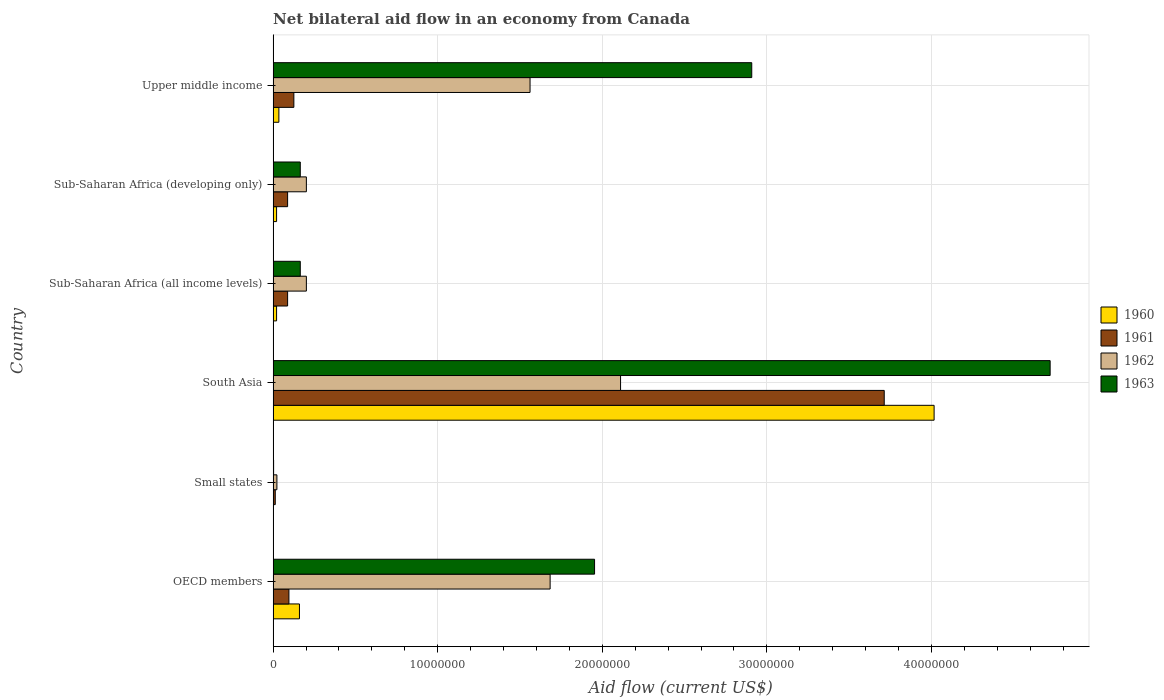How many groups of bars are there?
Your answer should be compact. 6. Are the number of bars on each tick of the Y-axis equal?
Keep it short and to the point. Yes. What is the label of the 6th group of bars from the top?
Ensure brevity in your answer.  OECD members. What is the net bilateral aid flow in 1963 in Sub-Saharan Africa (all income levels)?
Your answer should be compact. 1.65e+06. Across all countries, what is the maximum net bilateral aid flow in 1960?
Your response must be concise. 4.02e+07. In which country was the net bilateral aid flow in 1960 maximum?
Offer a very short reply. South Asia. In which country was the net bilateral aid flow in 1963 minimum?
Your answer should be compact. Small states. What is the total net bilateral aid flow in 1961 in the graph?
Your response must be concise. 4.12e+07. What is the difference between the net bilateral aid flow in 1961 in South Asia and that in Sub-Saharan Africa (all income levels)?
Your answer should be very brief. 3.62e+07. What is the difference between the net bilateral aid flow in 1963 in South Asia and the net bilateral aid flow in 1960 in Small states?
Keep it short and to the point. 4.72e+07. What is the average net bilateral aid flow in 1961 per country?
Ensure brevity in your answer.  6.87e+06. What is the difference between the net bilateral aid flow in 1963 and net bilateral aid flow in 1961 in OECD members?
Your answer should be very brief. 1.86e+07. In how many countries, is the net bilateral aid flow in 1960 greater than 28000000 US$?
Offer a very short reply. 1. What is the ratio of the net bilateral aid flow in 1961 in Small states to that in Sub-Saharan Africa (developing only)?
Your answer should be compact. 0.15. Is the net bilateral aid flow in 1962 in Sub-Saharan Africa (developing only) less than that in Upper middle income?
Offer a very short reply. Yes. Is the difference between the net bilateral aid flow in 1963 in Small states and Sub-Saharan Africa (developing only) greater than the difference between the net bilateral aid flow in 1961 in Small states and Sub-Saharan Africa (developing only)?
Offer a very short reply. No. What is the difference between the highest and the second highest net bilateral aid flow in 1961?
Offer a very short reply. 3.59e+07. What is the difference between the highest and the lowest net bilateral aid flow in 1961?
Make the answer very short. 3.70e+07. Is the sum of the net bilateral aid flow in 1960 in Small states and Upper middle income greater than the maximum net bilateral aid flow in 1963 across all countries?
Offer a terse response. No. How many countries are there in the graph?
Your answer should be compact. 6. What is the difference between two consecutive major ticks on the X-axis?
Keep it short and to the point. 1.00e+07. Are the values on the major ticks of X-axis written in scientific E-notation?
Offer a terse response. No. Does the graph contain any zero values?
Your answer should be very brief. No. Does the graph contain grids?
Provide a succinct answer. Yes. How many legend labels are there?
Your answer should be compact. 4. What is the title of the graph?
Provide a succinct answer. Net bilateral aid flow in an economy from Canada. What is the label or title of the X-axis?
Give a very brief answer. Aid flow (current US$). What is the label or title of the Y-axis?
Your answer should be very brief. Country. What is the Aid flow (current US$) of 1960 in OECD members?
Provide a short and direct response. 1.60e+06. What is the Aid flow (current US$) in 1961 in OECD members?
Your response must be concise. 9.60e+05. What is the Aid flow (current US$) in 1962 in OECD members?
Give a very brief answer. 1.68e+07. What is the Aid flow (current US$) of 1963 in OECD members?
Ensure brevity in your answer.  1.95e+07. What is the Aid flow (current US$) of 1960 in Small states?
Your answer should be very brief. 2.00e+04. What is the Aid flow (current US$) in 1962 in Small states?
Provide a short and direct response. 2.30e+05. What is the Aid flow (current US$) of 1960 in South Asia?
Offer a terse response. 4.02e+07. What is the Aid flow (current US$) of 1961 in South Asia?
Make the answer very short. 3.71e+07. What is the Aid flow (current US$) in 1962 in South Asia?
Offer a very short reply. 2.11e+07. What is the Aid flow (current US$) in 1963 in South Asia?
Offer a terse response. 4.72e+07. What is the Aid flow (current US$) of 1960 in Sub-Saharan Africa (all income levels)?
Keep it short and to the point. 2.10e+05. What is the Aid flow (current US$) in 1961 in Sub-Saharan Africa (all income levels)?
Ensure brevity in your answer.  8.80e+05. What is the Aid flow (current US$) in 1962 in Sub-Saharan Africa (all income levels)?
Offer a very short reply. 2.02e+06. What is the Aid flow (current US$) in 1963 in Sub-Saharan Africa (all income levels)?
Offer a terse response. 1.65e+06. What is the Aid flow (current US$) in 1961 in Sub-Saharan Africa (developing only)?
Give a very brief answer. 8.80e+05. What is the Aid flow (current US$) of 1962 in Sub-Saharan Africa (developing only)?
Provide a succinct answer. 2.02e+06. What is the Aid flow (current US$) of 1963 in Sub-Saharan Africa (developing only)?
Provide a short and direct response. 1.65e+06. What is the Aid flow (current US$) in 1960 in Upper middle income?
Give a very brief answer. 3.50e+05. What is the Aid flow (current US$) of 1961 in Upper middle income?
Offer a very short reply. 1.26e+06. What is the Aid flow (current US$) of 1962 in Upper middle income?
Your response must be concise. 1.56e+07. What is the Aid flow (current US$) in 1963 in Upper middle income?
Your answer should be compact. 2.91e+07. Across all countries, what is the maximum Aid flow (current US$) of 1960?
Give a very brief answer. 4.02e+07. Across all countries, what is the maximum Aid flow (current US$) of 1961?
Your answer should be very brief. 3.71e+07. Across all countries, what is the maximum Aid flow (current US$) in 1962?
Keep it short and to the point. 2.11e+07. Across all countries, what is the maximum Aid flow (current US$) of 1963?
Your answer should be compact. 4.72e+07. What is the total Aid flow (current US$) in 1960 in the graph?
Your answer should be compact. 4.26e+07. What is the total Aid flow (current US$) in 1961 in the graph?
Ensure brevity in your answer.  4.12e+07. What is the total Aid flow (current US$) in 1962 in the graph?
Provide a succinct answer. 5.78e+07. What is the total Aid flow (current US$) in 1963 in the graph?
Give a very brief answer. 9.92e+07. What is the difference between the Aid flow (current US$) in 1960 in OECD members and that in Small states?
Give a very brief answer. 1.58e+06. What is the difference between the Aid flow (current US$) of 1961 in OECD members and that in Small states?
Ensure brevity in your answer.  8.30e+05. What is the difference between the Aid flow (current US$) of 1962 in OECD members and that in Small states?
Provide a short and direct response. 1.66e+07. What is the difference between the Aid flow (current US$) of 1963 in OECD members and that in Small states?
Your answer should be very brief. 1.95e+07. What is the difference between the Aid flow (current US$) of 1960 in OECD members and that in South Asia?
Ensure brevity in your answer.  -3.86e+07. What is the difference between the Aid flow (current US$) in 1961 in OECD members and that in South Asia?
Provide a short and direct response. -3.62e+07. What is the difference between the Aid flow (current US$) in 1962 in OECD members and that in South Asia?
Offer a terse response. -4.28e+06. What is the difference between the Aid flow (current US$) of 1963 in OECD members and that in South Asia?
Offer a very short reply. -2.77e+07. What is the difference between the Aid flow (current US$) of 1960 in OECD members and that in Sub-Saharan Africa (all income levels)?
Offer a very short reply. 1.39e+06. What is the difference between the Aid flow (current US$) of 1962 in OECD members and that in Sub-Saharan Africa (all income levels)?
Your answer should be very brief. 1.48e+07. What is the difference between the Aid flow (current US$) of 1963 in OECD members and that in Sub-Saharan Africa (all income levels)?
Keep it short and to the point. 1.79e+07. What is the difference between the Aid flow (current US$) of 1960 in OECD members and that in Sub-Saharan Africa (developing only)?
Keep it short and to the point. 1.39e+06. What is the difference between the Aid flow (current US$) of 1961 in OECD members and that in Sub-Saharan Africa (developing only)?
Give a very brief answer. 8.00e+04. What is the difference between the Aid flow (current US$) of 1962 in OECD members and that in Sub-Saharan Africa (developing only)?
Offer a very short reply. 1.48e+07. What is the difference between the Aid flow (current US$) in 1963 in OECD members and that in Sub-Saharan Africa (developing only)?
Give a very brief answer. 1.79e+07. What is the difference between the Aid flow (current US$) of 1960 in OECD members and that in Upper middle income?
Your response must be concise. 1.25e+06. What is the difference between the Aid flow (current US$) in 1961 in OECD members and that in Upper middle income?
Offer a very short reply. -3.00e+05. What is the difference between the Aid flow (current US$) of 1962 in OECD members and that in Upper middle income?
Ensure brevity in your answer.  1.22e+06. What is the difference between the Aid flow (current US$) in 1963 in OECD members and that in Upper middle income?
Your answer should be compact. -9.55e+06. What is the difference between the Aid flow (current US$) of 1960 in Small states and that in South Asia?
Ensure brevity in your answer.  -4.01e+07. What is the difference between the Aid flow (current US$) of 1961 in Small states and that in South Asia?
Ensure brevity in your answer.  -3.70e+07. What is the difference between the Aid flow (current US$) in 1962 in Small states and that in South Asia?
Offer a very short reply. -2.09e+07. What is the difference between the Aid flow (current US$) of 1963 in Small states and that in South Asia?
Ensure brevity in your answer.  -4.72e+07. What is the difference between the Aid flow (current US$) in 1960 in Small states and that in Sub-Saharan Africa (all income levels)?
Offer a very short reply. -1.90e+05. What is the difference between the Aid flow (current US$) of 1961 in Small states and that in Sub-Saharan Africa (all income levels)?
Make the answer very short. -7.50e+05. What is the difference between the Aid flow (current US$) in 1962 in Small states and that in Sub-Saharan Africa (all income levels)?
Provide a short and direct response. -1.79e+06. What is the difference between the Aid flow (current US$) in 1963 in Small states and that in Sub-Saharan Africa (all income levels)?
Give a very brief answer. -1.62e+06. What is the difference between the Aid flow (current US$) of 1961 in Small states and that in Sub-Saharan Africa (developing only)?
Give a very brief answer. -7.50e+05. What is the difference between the Aid flow (current US$) in 1962 in Small states and that in Sub-Saharan Africa (developing only)?
Your answer should be very brief. -1.79e+06. What is the difference between the Aid flow (current US$) in 1963 in Small states and that in Sub-Saharan Africa (developing only)?
Provide a short and direct response. -1.62e+06. What is the difference between the Aid flow (current US$) of 1960 in Small states and that in Upper middle income?
Give a very brief answer. -3.30e+05. What is the difference between the Aid flow (current US$) in 1961 in Small states and that in Upper middle income?
Offer a very short reply. -1.13e+06. What is the difference between the Aid flow (current US$) in 1962 in Small states and that in Upper middle income?
Offer a very short reply. -1.54e+07. What is the difference between the Aid flow (current US$) in 1963 in Small states and that in Upper middle income?
Offer a very short reply. -2.90e+07. What is the difference between the Aid flow (current US$) in 1960 in South Asia and that in Sub-Saharan Africa (all income levels)?
Your answer should be very brief. 4.00e+07. What is the difference between the Aid flow (current US$) in 1961 in South Asia and that in Sub-Saharan Africa (all income levels)?
Offer a very short reply. 3.62e+07. What is the difference between the Aid flow (current US$) of 1962 in South Asia and that in Sub-Saharan Africa (all income levels)?
Your answer should be very brief. 1.91e+07. What is the difference between the Aid flow (current US$) of 1963 in South Asia and that in Sub-Saharan Africa (all income levels)?
Give a very brief answer. 4.56e+07. What is the difference between the Aid flow (current US$) in 1960 in South Asia and that in Sub-Saharan Africa (developing only)?
Your response must be concise. 4.00e+07. What is the difference between the Aid flow (current US$) in 1961 in South Asia and that in Sub-Saharan Africa (developing only)?
Your response must be concise. 3.62e+07. What is the difference between the Aid flow (current US$) in 1962 in South Asia and that in Sub-Saharan Africa (developing only)?
Keep it short and to the point. 1.91e+07. What is the difference between the Aid flow (current US$) of 1963 in South Asia and that in Sub-Saharan Africa (developing only)?
Provide a short and direct response. 4.56e+07. What is the difference between the Aid flow (current US$) in 1960 in South Asia and that in Upper middle income?
Ensure brevity in your answer.  3.98e+07. What is the difference between the Aid flow (current US$) in 1961 in South Asia and that in Upper middle income?
Provide a succinct answer. 3.59e+07. What is the difference between the Aid flow (current US$) of 1962 in South Asia and that in Upper middle income?
Provide a succinct answer. 5.50e+06. What is the difference between the Aid flow (current US$) in 1963 in South Asia and that in Upper middle income?
Ensure brevity in your answer.  1.81e+07. What is the difference between the Aid flow (current US$) in 1963 in Sub-Saharan Africa (all income levels) and that in Sub-Saharan Africa (developing only)?
Your response must be concise. 0. What is the difference between the Aid flow (current US$) of 1961 in Sub-Saharan Africa (all income levels) and that in Upper middle income?
Offer a terse response. -3.80e+05. What is the difference between the Aid flow (current US$) of 1962 in Sub-Saharan Africa (all income levels) and that in Upper middle income?
Provide a succinct answer. -1.36e+07. What is the difference between the Aid flow (current US$) in 1963 in Sub-Saharan Africa (all income levels) and that in Upper middle income?
Your answer should be compact. -2.74e+07. What is the difference between the Aid flow (current US$) in 1961 in Sub-Saharan Africa (developing only) and that in Upper middle income?
Your answer should be very brief. -3.80e+05. What is the difference between the Aid flow (current US$) in 1962 in Sub-Saharan Africa (developing only) and that in Upper middle income?
Offer a very short reply. -1.36e+07. What is the difference between the Aid flow (current US$) of 1963 in Sub-Saharan Africa (developing only) and that in Upper middle income?
Your response must be concise. -2.74e+07. What is the difference between the Aid flow (current US$) of 1960 in OECD members and the Aid flow (current US$) of 1961 in Small states?
Offer a very short reply. 1.47e+06. What is the difference between the Aid flow (current US$) of 1960 in OECD members and the Aid flow (current US$) of 1962 in Small states?
Offer a very short reply. 1.37e+06. What is the difference between the Aid flow (current US$) in 1960 in OECD members and the Aid flow (current US$) in 1963 in Small states?
Your answer should be very brief. 1.57e+06. What is the difference between the Aid flow (current US$) in 1961 in OECD members and the Aid flow (current US$) in 1962 in Small states?
Keep it short and to the point. 7.30e+05. What is the difference between the Aid flow (current US$) in 1961 in OECD members and the Aid flow (current US$) in 1963 in Small states?
Provide a short and direct response. 9.30e+05. What is the difference between the Aid flow (current US$) of 1962 in OECD members and the Aid flow (current US$) of 1963 in Small states?
Your answer should be compact. 1.68e+07. What is the difference between the Aid flow (current US$) in 1960 in OECD members and the Aid flow (current US$) in 1961 in South Asia?
Offer a terse response. -3.55e+07. What is the difference between the Aid flow (current US$) in 1960 in OECD members and the Aid flow (current US$) in 1962 in South Asia?
Give a very brief answer. -1.95e+07. What is the difference between the Aid flow (current US$) of 1960 in OECD members and the Aid flow (current US$) of 1963 in South Asia?
Your answer should be very brief. -4.56e+07. What is the difference between the Aid flow (current US$) of 1961 in OECD members and the Aid flow (current US$) of 1962 in South Asia?
Give a very brief answer. -2.02e+07. What is the difference between the Aid flow (current US$) of 1961 in OECD members and the Aid flow (current US$) of 1963 in South Asia?
Provide a short and direct response. -4.62e+07. What is the difference between the Aid flow (current US$) in 1962 in OECD members and the Aid flow (current US$) in 1963 in South Asia?
Provide a succinct answer. -3.04e+07. What is the difference between the Aid flow (current US$) in 1960 in OECD members and the Aid flow (current US$) in 1961 in Sub-Saharan Africa (all income levels)?
Your answer should be compact. 7.20e+05. What is the difference between the Aid flow (current US$) of 1960 in OECD members and the Aid flow (current US$) of 1962 in Sub-Saharan Africa (all income levels)?
Offer a very short reply. -4.20e+05. What is the difference between the Aid flow (current US$) of 1961 in OECD members and the Aid flow (current US$) of 1962 in Sub-Saharan Africa (all income levels)?
Ensure brevity in your answer.  -1.06e+06. What is the difference between the Aid flow (current US$) of 1961 in OECD members and the Aid flow (current US$) of 1963 in Sub-Saharan Africa (all income levels)?
Your response must be concise. -6.90e+05. What is the difference between the Aid flow (current US$) of 1962 in OECD members and the Aid flow (current US$) of 1963 in Sub-Saharan Africa (all income levels)?
Offer a terse response. 1.52e+07. What is the difference between the Aid flow (current US$) in 1960 in OECD members and the Aid flow (current US$) in 1961 in Sub-Saharan Africa (developing only)?
Your answer should be compact. 7.20e+05. What is the difference between the Aid flow (current US$) in 1960 in OECD members and the Aid flow (current US$) in 1962 in Sub-Saharan Africa (developing only)?
Provide a short and direct response. -4.20e+05. What is the difference between the Aid flow (current US$) of 1961 in OECD members and the Aid flow (current US$) of 1962 in Sub-Saharan Africa (developing only)?
Your answer should be compact. -1.06e+06. What is the difference between the Aid flow (current US$) in 1961 in OECD members and the Aid flow (current US$) in 1963 in Sub-Saharan Africa (developing only)?
Make the answer very short. -6.90e+05. What is the difference between the Aid flow (current US$) of 1962 in OECD members and the Aid flow (current US$) of 1963 in Sub-Saharan Africa (developing only)?
Make the answer very short. 1.52e+07. What is the difference between the Aid flow (current US$) in 1960 in OECD members and the Aid flow (current US$) in 1962 in Upper middle income?
Your answer should be compact. -1.40e+07. What is the difference between the Aid flow (current US$) of 1960 in OECD members and the Aid flow (current US$) of 1963 in Upper middle income?
Your answer should be compact. -2.75e+07. What is the difference between the Aid flow (current US$) in 1961 in OECD members and the Aid flow (current US$) in 1962 in Upper middle income?
Provide a succinct answer. -1.46e+07. What is the difference between the Aid flow (current US$) in 1961 in OECD members and the Aid flow (current US$) in 1963 in Upper middle income?
Give a very brief answer. -2.81e+07. What is the difference between the Aid flow (current US$) of 1962 in OECD members and the Aid flow (current US$) of 1963 in Upper middle income?
Offer a terse response. -1.22e+07. What is the difference between the Aid flow (current US$) in 1960 in Small states and the Aid flow (current US$) in 1961 in South Asia?
Provide a succinct answer. -3.71e+07. What is the difference between the Aid flow (current US$) of 1960 in Small states and the Aid flow (current US$) of 1962 in South Asia?
Provide a succinct answer. -2.11e+07. What is the difference between the Aid flow (current US$) in 1960 in Small states and the Aid flow (current US$) in 1963 in South Asia?
Ensure brevity in your answer.  -4.72e+07. What is the difference between the Aid flow (current US$) in 1961 in Small states and the Aid flow (current US$) in 1962 in South Asia?
Your response must be concise. -2.10e+07. What is the difference between the Aid flow (current US$) in 1961 in Small states and the Aid flow (current US$) in 1963 in South Asia?
Make the answer very short. -4.71e+07. What is the difference between the Aid flow (current US$) in 1962 in Small states and the Aid flow (current US$) in 1963 in South Asia?
Your response must be concise. -4.70e+07. What is the difference between the Aid flow (current US$) in 1960 in Small states and the Aid flow (current US$) in 1961 in Sub-Saharan Africa (all income levels)?
Provide a succinct answer. -8.60e+05. What is the difference between the Aid flow (current US$) in 1960 in Small states and the Aid flow (current US$) in 1962 in Sub-Saharan Africa (all income levels)?
Your answer should be compact. -2.00e+06. What is the difference between the Aid flow (current US$) of 1960 in Small states and the Aid flow (current US$) of 1963 in Sub-Saharan Africa (all income levels)?
Provide a succinct answer. -1.63e+06. What is the difference between the Aid flow (current US$) in 1961 in Small states and the Aid flow (current US$) in 1962 in Sub-Saharan Africa (all income levels)?
Your answer should be very brief. -1.89e+06. What is the difference between the Aid flow (current US$) in 1961 in Small states and the Aid flow (current US$) in 1963 in Sub-Saharan Africa (all income levels)?
Offer a very short reply. -1.52e+06. What is the difference between the Aid flow (current US$) in 1962 in Small states and the Aid flow (current US$) in 1963 in Sub-Saharan Africa (all income levels)?
Make the answer very short. -1.42e+06. What is the difference between the Aid flow (current US$) in 1960 in Small states and the Aid flow (current US$) in 1961 in Sub-Saharan Africa (developing only)?
Give a very brief answer. -8.60e+05. What is the difference between the Aid flow (current US$) of 1960 in Small states and the Aid flow (current US$) of 1963 in Sub-Saharan Africa (developing only)?
Keep it short and to the point. -1.63e+06. What is the difference between the Aid flow (current US$) of 1961 in Small states and the Aid flow (current US$) of 1962 in Sub-Saharan Africa (developing only)?
Your answer should be very brief. -1.89e+06. What is the difference between the Aid flow (current US$) in 1961 in Small states and the Aid flow (current US$) in 1963 in Sub-Saharan Africa (developing only)?
Your answer should be very brief. -1.52e+06. What is the difference between the Aid flow (current US$) of 1962 in Small states and the Aid flow (current US$) of 1963 in Sub-Saharan Africa (developing only)?
Offer a very short reply. -1.42e+06. What is the difference between the Aid flow (current US$) of 1960 in Small states and the Aid flow (current US$) of 1961 in Upper middle income?
Offer a very short reply. -1.24e+06. What is the difference between the Aid flow (current US$) of 1960 in Small states and the Aid flow (current US$) of 1962 in Upper middle income?
Provide a short and direct response. -1.56e+07. What is the difference between the Aid flow (current US$) of 1960 in Small states and the Aid flow (current US$) of 1963 in Upper middle income?
Provide a succinct answer. -2.91e+07. What is the difference between the Aid flow (current US$) in 1961 in Small states and the Aid flow (current US$) in 1962 in Upper middle income?
Ensure brevity in your answer.  -1.55e+07. What is the difference between the Aid flow (current US$) in 1961 in Small states and the Aid flow (current US$) in 1963 in Upper middle income?
Provide a short and direct response. -2.90e+07. What is the difference between the Aid flow (current US$) in 1962 in Small states and the Aid flow (current US$) in 1963 in Upper middle income?
Offer a very short reply. -2.88e+07. What is the difference between the Aid flow (current US$) in 1960 in South Asia and the Aid flow (current US$) in 1961 in Sub-Saharan Africa (all income levels)?
Keep it short and to the point. 3.93e+07. What is the difference between the Aid flow (current US$) in 1960 in South Asia and the Aid flow (current US$) in 1962 in Sub-Saharan Africa (all income levels)?
Keep it short and to the point. 3.81e+07. What is the difference between the Aid flow (current US$) in 1960 in South Asia and the Aid flow (current US$) in 1963 in Sub-Saharan Africa (all income levels)?
Keep it short and to the point. 3.85e+07. What is the difference between the Aid flow (current US$) in 1961 in South Asia and the Aid flow (current US$) in 1962 in Sub-Saharan Africa (all income levels)?
Offer a very short reply. 3.51e+07. What is the difference between the Aid flow (current US$) in 1961 in South Asia and the Aid flow (current US$) in 1963 in Sub-Saharan Africa (all income levels)?
Your response must be concise. 3.55e+07. What is the difference between the Aid flow (current US$) of 1962 in South Asia and the Aid flow (current US$) of 1963 in Sub-Saharan Africa (all income levels)?
Your answer should be very brief. 1.95e+07. What is the difference between the Aid flow (current US$) of 1960 in South Asia and the Aid flow (current US$) of 1961 in Sub-Saharan Africa (developing only)?
Your response must be concise. 3.93e+07. What is the difference between the Aid flow (current US$) in 1960 in South Asia and the Aid flow (current US$) in 1962 in Sub-Saharan Africa (developing only)?
Provide a succinct answer. 3.81e+07. What is the difference between the Aid flow (current US$) in 1960 in South Asia and the Aid flow (current US$) in 1963 in Sub-Saharan Africa (developing only)?
Offer a terse response. 3.85e+07. What is the difference between the Aid flow (current US$) of 1961 in South Asia and the Aid flow (current US$) of 1962 in Sub-Saharan Africa (developing only)?
Your response must be concise. 3.51e+07. What is the difference between the Aid flow (current US$) in 1961 in South Asia and the Aid flow (current US$) in 1963 in Sub-Saharan Africa (developing only)?
Your response must be concise. 3.55e+07. What is the difference between the Aid flow (current US$) of 1962 in South Asia and the Aid flow (current US$) of 1963 in Sub-Saharan Africa (developing only)?
Make the answer very short. 1.95e+07. What is the difference between the Aid flow (current US$) of 1960 in South Asia and the Aid flow (current US$) of 1961 in Upper middle income?
Provide a short and direct response. 3.89e+07. What is the difference between the Aid flow (current US$) of 1960 in South Asia and the Aid flow (current US$) of 1962 in Upper middle income?
Ensure brevity in your answer.  2.46e+07. What is the difference between the Aid flow (current US$) of 1960 in South Asia and the Aid flow (current US$) of 1963 in Upper middle income?
Keep it short and to the point. 1.11e+07. What is the difference between the Aid flow (current US$) in 1961 in South Asia and the Aid flow (current US$) in 1962 in Upper middle income?
Provide a short and direct response. 2.15e+07. What is the difference between the Aid flow (current US$) in 1961 in South Asia and the Aid flow (current US$) in 1963 in Upper middle income?
Offer a terse response. 8.05e+06. What is the difference between the Aid flow (current US$) of 1962 in South Asia and the Aid flow (current US$) of 1963 in Upper middle income?
Keep it short and to the point. -7.97e+06. What is the difference between the Aid flow (current US$) in 1960 in Sub-Saharan Africa (all income levels) and the Aid flow (current US$) in 1961 in Sub-Saharan Africa (developing only)?
Your answer should be compact. -6.70e+05. What is the difference between the Aid flow (current US$) in 1960 in Sub-Saharan Africa (all income levels) and the Aid flow (current US$) in 1962 in Sub-Saharan Africa (developing only)?
Provide a short and direct response. -1.81e+06. What is the difference between the Aid flow (current US$) of 1960 in Sub-Saharan Africa (all income levels) and the Aid flow (current US$) of 1963 in Sub-Saharan Africa (developing only)?
Provide a succinct answer. -1.44e+06. What is the difference between the Aid flow (current US$) of 1961 in Sub-Saharan Africa (all income levels) and the Aid flow (current US$) of 1962 in Sub-Saharan Africa (developing only)?
Provide a succinct answer. -1.14e+06. What is the difference between the Aid flow (current US$) in 1961 in Sub-Saharan Africa (all income levels) and the Aid flow (current US$) in 1963 in Sub-Saharan Africa (developing only)?
Ensure brevity in your answer.  -7.70e+05. What is the difference between the Aid flow (current US$) of 1960 in Sub-Saharan Africa (all income levels) and the Aid flow (current US$) of 1961 in Upper middle income?
Offer a terse response. -1.05e+06. What is the difference between the Aid flow (current US$) in 1960 in Sub-Saharan Africa (all income levels) and the Aid flow (current US$) in 1962 in Upper middle income?
Keep it short and to the point. -1.54e+07. What is the difference between the Aid flow (current US$) of 1960 in Sub-Saharan Africa (all income levels) and the Aid flow (current US$) of 1963 in Upper middle income?
Your answer should be compact. -2.89e+07. What is the difference between the Aid flow (current US$) of 1961 in Sub-Saharan Africa (all income levels) and the Aid flow (current US$) of 1962 in Upper middle income?
Provide a short and direct response. -1.47e+07. What is the difference between the Aid flow (current US$) of 1961 in Sub-Saharan Africa (all income levels) and the Aid flow (current US$) of 1963 in Upper middle income?
Your response must be concise. -2.82e+07. What is the difference between the Aid flow (current US$) of 1962 in Sub-Saharan Africa (all income levels) and the Aid flow (current US$) of 1963 in Upper middle income?
Provide a short and direct response. -2.71e+07. What is the difference between the Aid flow (current US$) in 1960 in Sub-Saharan Africa (developing only) and the Aid flow (current US$) in 1961 in Upper middle income?
Your answer should be very brief. -1.05e+06. What is the difference between the Aid flow (current US$) in 1960 in Sub-Saharan Africa (developing only) and the Aid flow (current US$) in 1962 in Upper middle income?
Provide a short and direct response. -1.54e+07. What is the difference between the Aid flow (current US$) in 1960 in Sub-Saharan Africa (developing only) and the Aid flow (current US$) in 1963 in Upper middle income?
Your answer should be compact. -2.89e+07. What is the difference between the Aid flow (current US$) in 1961 in Sub-Saharan Africa (developing only) and the Aid flow (current US$) in 1962 in Upper middle income?
Provide a short and direct response. -1.47e+07. What is the difference between the Aid flow (current US$) in 1961 in Sub-Saharan Africa (developing only) and the Aid flow (current US$) in 1963 in Upper middle income?
Provide a succinct answer. -2.82e+07. What is the difference between the Aid flow (current US$) in 1962 in Sub-Saharan Africa (developing only) and the Aid flow (current US$) in 1963 in Upper middle income?
Make the answer very short. -2.71e+07. What is the average Aid flow (current US$) of 1960 per country?
Make the answer very short. 7.09e+06. What is the average Aid flow (current US$) of 1961 per country?
Offer a very short reply. 6.87e+06. What is the average Aid flow (current US$) of 1962 per country?
Make the answer very short. 9.64e+06. What is the average Aid flow (current US$) of 1963 per country?
Your answer should be compact. 1.65e+07. What is the difference between the Aid flow (current US$) of 1960 and Aid flow (current US$) of 1961 in OECD members?
Make the answer very short. 6.40e+05. What is the difference between the Aid flow (current US$) of 1960 and Aid flow (current US$) of 1962 in OECD members?
Make the answer very short. -1.52e+07. What is the difference between the Aid flow (current US$) in 1960 and Aid flow (current US$) in 1963 in OECD members?
Your response must be concise. -1.79e+07. What is the difference between the Aid flow (current US$) in 1961 and Aid flow (current US$) in 1962 in OECD members?
Keep it short and to the point. -1.59e+07. What is the difference between the Aid flow (current US$) in 1961 and Aid flow (current US$) in 1963 in OECD members?
Offer a terse response. -1.86e+07. What is the difference between the Aid flow (current US$) in 1962 and Aid flow (current US$) in 1963 in OECD members?
Offer a very short reply. -2.70e+06. What is the difference between the Aid flow (current US$) in 1960 and Aid flow (current US$) in 1961 in Small states?
Make the answer very short. -1.10e+05. What is the difference between the Aid flow (current US$) in 1960 and Aid flow (current US$) in 1962 in Small states?
Your response must be concise. -2.10e+05. What is the difference between the Aid flow (current US$) of 1961 and Aid flow (current US$) of 1962 in Small states?
Make the answer very short. -1.00e+05. What is the difference between the Aid flow (current US$) of 1960 and Aid flow (current US$) of 1961 in South Asia?
Your response must be concise. 3.03e+06. What is the difference between the Aid flow (current US$) in 1960 and Aid flow (current US$) in 1962 in South Asia?
Provide a short and direct response. 1.90e+07. What is the difference between the Aid flow (current US$) in 1960 and Aid flow (current US$) in 1963 in South Asia?
Keep it short and to the point. -7.05e+06. What is the difference between the Aid flow (current US$) in 1961 and Aid flow (current US$) in 1962 in South Asia?
Provide a succinct answer. 1.60e+07. What is the difference between the Aid flow (current US$) of 1961 and Aid flow (current US$) of 1963 in South Asia?
Your response must be concise. -1.01e+07. What is the difference between the Aid flow (current US$) of 1962 and Aid flow (current US$) of 1963 in South Asia?
Make the answer very short. -2.61e+07. What is the difference between the Aid flow (current US$) of 1960 and Aid flow (current US$) of 1961 in Sub-Saharan Africa (all income levels)?
Give a very brief answer. -6.70e+05. What is the difference between the Aid flow (current US$) of 1960 and Aid flow (current US$) of 1962 in Sub-Saharan Africa (all income levels)?
Your answer should be very brief. -1.81e+06. What is the difference between the Aid flow (current US$) of 1960 and Aid flow (current US$) of 1963 in Sub-Saharan Africa (all income levels)?
Provide a short and direct response. -1.44e+06. What is the difference between the Aid flow (current US$) of 1961 and Aid flow (current US$) of 1962 in Sub-Saharan Africa (all income levels)?
Your response must be concise. -1.14e+06. What is the difference between the Aid flow (current US$) of 1961 and Aid flow (current US$) of 1963 in Sub-Saharan Africa (all income levels)?
Your response must be concise. -7.70e+05. What is the difference between the Aid flow (current US$) of 1960 and Aid flow (current US$) of 1961 in Sub-Saharan Africa (developing only)?
Provide a succinct answer. -6.70e+05. What is the difference between the Aid flow (current US$) of 1960 and Aid flow (current US$) of 1962 in Sub-Saharan Africa (developing only)?
Offer a very short reply. -1.81e+06. What is the difference between the Aid flow (current US$) in 1960 and Aid flow (current US$) in 1963 in Sub-Saharan Africa (developing only)?
Provide a succinct answer. -1.44e+06. What is the difference between the Aid flow (current US$) of 1961 and Aid flow (current US$) of 1962 in Sub-Saharan Africa (developing only)?
Provide a succinct answer. -1.14e+06. What is the difference between the Aid flow (current US$) in 1961 and Aid flow (current US$) in 1963 in Sub-Saharan Africa (developing only)?
Give a very brief answer. -7.70e+05. What is the difference between the Aid flow (current US$) in 1960 and Aid flow (current US$) in 1961 in Upper middle income?
Your answer should be compact. -9.10e+05. What is the difference between the Aid flow (current US$) in 1960 and Aid flow (current US$) in 1962 in Upper middle income?
Give a very brief answer. -1.53e+07. What is the difference between the Aid flow (current US$) of 1960 and Aid flow (current US$) of 1963 in Upper middle income?
Offer a terse response. -2.87e+07. What is the difference between the Aid flow (current US$) in 1961 and Aid flow (current US$) in 1962 in Upper middle income?
Make the answer very short. -1.44e+07. What is the difference between the Aid flow (current US$) in 1961 and Aid flow (current US$) in 1963 in Upper middle income?
Give a very brief answer. -2.78e+07. What is the difference between the Aid flow (current US$) of 1962 and Aid flow (current US$) of 1963 in Upper middle income?
Provide a short and direct response. -1.35e+07. What is the ratio of the Aid flow (current US$) of 1960 in OECD members to that in Small states?
Provide a succinct answer. 80. What is the ratio of the Aid flow (current US$) of 1961 in OECD members to that in Small states?
Your answer should be compact. 7.38. What is the ratio of the Aid flow (current US$) in 1962 in OECD members to that in Small states?
Your answer should be very brief. 73.17. What is the ratio of the Aid flow (current US$) of 1963 in OECD members to that in Small states?
Keep it short and to the point. 651. What is the ratio of the Aid flow (current US$) in 1960 in OECD members to that in South Asia?
Keep it short and to the point. 0.04. What is the ratio of the Aid flow (current US$) in 1961 in OECD members to that in South Asia?
Ensure brevity in your answer.  0.03. What is the ratio of the Aid flow (current US$) in 1962 in OECD members to that in South Asia?
Your answer should be compact. 0.8. What is the ratio of the Aid flow (current US$) of 1963 in OECD members to that in South Asia?
Your answer should be very brief. 0.41. What is the ratio of the Aid flow (current US$) in 1960 in OECD members to that in Sub-Saharan Africa (all income levels)?
Keep it short and to the point. 7.62. What is the ratio of the Aid flow (current US$) in 1961 in OECD members to that in Sub-Saharan Africa (all income levels)?
Keep it short and to the point. 1.09. What is the ratio of the Aid flow (current US$) in 1962 in OECD members to that in Sub-Saharan Africa (all income levels)?
Provide a succinct answer. 8.33. What is the ratio of the Aid flow (current US$) of 1963 in OECD members to that in Sub-Saharan Africa (all income levels)?
Offer a very short reply. 11.84. What is the ratio of the Aid flow (current US$) in 1960 in OECD members to that in Sub-Saharan Africa (developing only)?
Your response must be concise. 7.62. What is the ratio of the Aid flow (current US$) of 1961 in OECD members to that in Sub-Saharan Africa (developing only)?
Offer a terse response. 1.09. What is the ratio of the Aid flow (current US$) of 1962 in OECD members to that in Sub-Saharan Africa (developing only)?
Give a very brief answer. 8.33. What is the ratio of the Aid flow (current US$) in 1963 in OECD members to that in Sub-Saharan Africa (developing only)?
Offer a very short reply. 11.84. What is the ratio of the Aid flow (current US$) in 1960 in OECD members to that in Upper middle income?
Keep it short and to the point. 4.57. What is the ratio of the Aid flow (current US$) of 1961 in OECD members to that in Upper middle income?
Make the answer very short. 0.76. What is the ratio of the Aid flow (current US$) in 1962 in OECD members to that in Upper middle income?
Your answer should be very brief. 1.08. What is the ratio of the Aid flow (current US$) of 1963 in OECD members to that in Upper middle income?
Your response must be concise. 0.67. What is the ratio of the Aid flow (current US$) of 1960 in Small states to that in South Asia?
Ensure brevity in your answer.  0. What is the ratio of the Aid flow (current US$) in 1961 in Small states to that in South Asia?
Provide a short and direct response. 0. What is the ratio of the Aid flow (current US$) of 1962 in Small states to that in South Asia?
Give a very brief answer. 0.01. What is the ratio of the Aid flow (current US$) of 1963 in Small states to that in South Asia?
Make the answer very short. 0. What is the ratio of the Aid flow (current US$) in 1960 in Small states to that in Sub-Saharan Africa (all income levels)?
Offer a very short reply. 0.1. What is the ratio of the Aid flow (current US$) of 1961 in Small states to that in Sub-Saharan Africa (all income levels)?
Your answer should be compact. 0.15. What is the ratio of the Aid flow (current US$) in 1962 in Small states to that in Sub-Saharan Africa (all income levels)?
Offer a terse response. 0.11. What is the ratio of the Aid flow (current US$) in 1963 in Small states to that in Sub-Saharan Africa (all income levels)?
Provide a short and direct response. 0.02. What is the ratio of the Aid flow (current US$) in 1960 in Small states to that in Sub-Saharan Africa (developing only)?
Offer a very short reply. 0.1. What is the ratio of the Aid flow (current US$) in 1961 in Small states to that in Sub-Saharan Africa (developing only)?
Provide a succinct answer. 0.15. What is the ratio of the Aid flow (current US$) of 1962 in Small states to that in Sub-Saharan Africa (developing only)?
Offer a terse response. 0.11. What is the ratio of the Aid flow (current US$) in 1963 in Small states to that in Sub-Saharan Africa (developing only)?
Offer a terse response. 0.02. What is the ratio of the Aid flow (current US$) of 1960 in Small states to that in Upper middle income?
Provide a short and direct response. 0.06. What is the ratio of the Aid flow (current US$) of 1961 in Small states to that in Upper middle income?
Your answer should be very brief. 0.1. What is the ratio of the Aid flow (current US$) in 1962 in Small states to that in Upper middle income?
Your response must be concise. 0.01. What is the ratio of the Aid flow (current US$) in 1960 in South Asia to that in Sub-Saharan Africa (all income levels)?
Offer a very short reply. 191.24. What is the ratio of the Aid flow (current US$) of 1961 in South Asia to that in Sub-Saharan Africa (all income levels)?
Your answer should be very brief. 42.19. What is the ratio of the Aid flow (current US$) of 1962 in South Asia to that in Sub-Saharan Africa (all income levels)?
Provide a short and direct response. 10.45. What is the ratio of the Aid flow (current US$) of 1963 in South Asia to that in Sub-Saharan Africa (all income levels)?
Your response must be concise. 28.61. What is the ratio of the Aid flow (current US$) in 1960 in South Asia to that in Sub-Saharan Africa (developing only)?
Keep it short and to the point. 191.24. What is the ratio of the Aid flow (current US$) of 1961 in South Asia to that in Sub-Saharan Africa (developing only)?
Offer a very short reply. 42.19. What is the ratio of the Aid flow (current US$) in 1962 in South Asia to that in Sub-Saharan Africa (developing only)?
Offer a very short reply. 10.45. What is the ratio of the Aid flow (current US$) of 1963 in South Asia to that in Sub-Saharan Africa (developing only)?
Keep it short and to the point. 28.61. What is the ratio of the Aid flow (current US$) of 1960 in South Asia to that in Upper middle income?
Give a very brief answer. 114.74. What is the ratio of the Aid flow (current US$) of 1961 in South Asia to that in Upper middle income?
Make the answer very short. 29.47. What is the ratio of the Aid flow (current US$) in 1962 in South Asia to that in Upper middle income?
Your response must be concise. 1.35. What is the ratio of the Aid flow (current US$) in 1963 in South Asia to that in Upper middle income?
Keep it short and to the point. 1.62. What is the ratio of the Aid flow (current US$) in 1961 in Sub-Saharan Africa (all income levels) to that in Sub-Saharan Africa (developing only)?
Your answer should be compact. 1. What is the ratio of the Aid flow (current US$) in 1961 in Sub-Saharan Africa (all income levels) to that in Upper middle income?
Offer a terse response. 0.7. What is the ratio of the Aid flow (current US$) of 1962 in Sub-Saharan Africa (all income levels) to that in Upper middle income?
Your answer should be compact. 0.13. What is the ratio of the Aid flow (current US$) of 1963 in Sub-Saharan Africa (all income levels) to that in Upper middle income?
Provide a short and direct response. 0.06. What is the ratio of the Aid flow (current US$) in 1960 in Sub-Saharan Africa (developing only) to that in Upper middle income?
Your answer should be very brief. 0.6. What is the ratio of the Aid flow (current US$) in 1961 in Sub-Saharan Africa (developing only) to that in Upper middle income?
Your answer should be compact. 0.7. What is the ratio of the Aid flow (current US$) of 1962 in Sub-Saharan Africa (developing only) to that in Upper middle income?
Offer a terse response. 0.13. What is the ratio of the Aid flow (current US$) of 1963 in Sub-Saharan Africa (developing only) to that in Upper middle income?
Provide a succinct answer. 0.06. What is the difference between the highest and the second highest Aid flow (current US$) in 1960?
Your response must be concise. 3.86e+07. What is the difference between the highest and the second highest Aid flow (current US$) of 1961?
Keep it short and to the point. 3.59e+07. What is the difference between the highest and the second highest Aid flow (current US$) in 1962?
Ensure brevity in your answer.  4.28e+06. What is the difference between the highest and the second highest Aid flow (current US$) of 1963?
Your response must be concise. 1.81e+07. What is the difference between the highest and the lowest Aid flow (current US$) in 1960?
Provide a succinct answer. 4.01e+07. What is the difference between the highest and the lowest Aid flow (current US$) in 1961?
Your answer should be very brief. 3.70e+07. What is the difference between the highest and the lowest Aid flow (current US$) of 1962?
Give a very brief answer. 2.09e+07. What is the difference between the highest and the lowest Aid flow (current US$) of 1963?
Ensure brevity in your answer.  4.72e+07. 